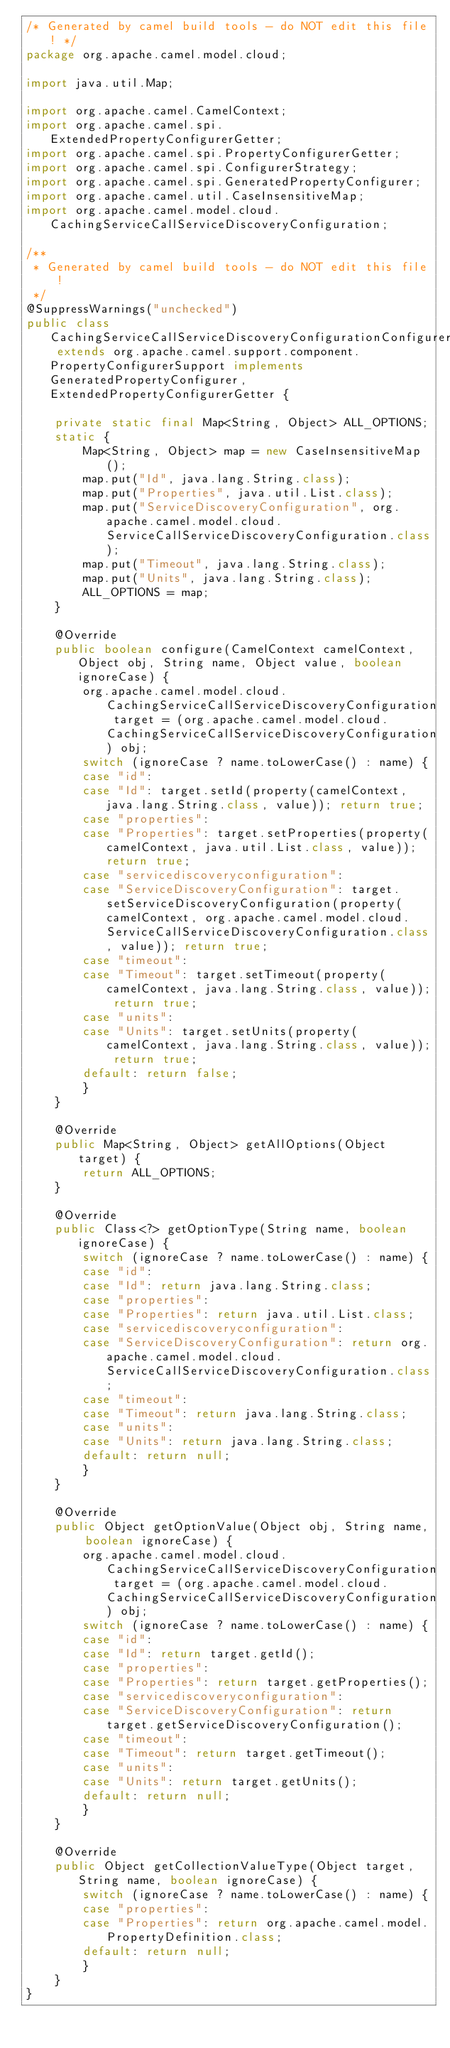<code> <loc_0><loc_0><loc_500><loc_500><_Java_>/* Generated by camel build tools - do NOT edit this file! */
package org.apache.camel.model.cloud;

import java.util.Map;

import org.apache.camel.CamelContext;
import org.apache.camel.spi.ExtendedPropertyConfigurerGetter;
import org.apache.camel.spi.PropertyConfigurerGetter;
import org.apache.camel.spi.ConfigurerStrategy;
import org.apache.camel.spi.GeneratedPropertyConfigurer;
import org.apache.camel.util.CaseInsensitiveMap;
import org.apache.camel.model.cloud.CachingServiceCallServiceDiscoveryConfiguration;

/**
 * Generated by camel build tools - do NOT edit this file!
 */
@SuppressWarnings("unchecked")
public class CachingServiceCallServiceDiscoveryConfigurationConfigurer extends org.apache.camel.support.component.PropertyConfigurerSupport implements GeneratedPropertyConfigurer, ExtendedPropertyConfigurerGetter {

    private static final Map<String, Object> ALL_OPTIONS;
    static {
        Map<String, Object> map = new CaseInsensitiveMap();
        map.put("Id", java.lang.String.class);
        map.put("Properties", java.util.List.class);
        map.put("ServiceDiscoveryConfiguration", org.apache.camel.model.cloud.ServiceCallServiceDiscoveryConfiguration.class);
        map.put("Timeout", java.lang.String.class);
        map.put("Units", java.lang.String.class);
        ALL_OPTIONS = map;
    }

    @Override
    public boolean configure(CamelContext camelContext, Object obj, String name, Object value, boolean ignoreCase) {
        org.apache.camel.model.cloud.CachingServiceCallServiceDiscoveryConfiguration target = (org.apache.camel.model.cloud.CachingServiceCallServiceDiscoveryConfiguration) obj;
        switch (ignoreCase ? name.toLowerCase() : name) {
        case "id":
        case "Id": target.setId(property(camelContext, java.lang.String.class, value)); return true;
        case "properties":
        case "Properties": target.setProperties(property(camelContext, java.util.List.class, value)); return true;
        case "servicediscoveryconfiguration":
        case "ServiceDiscoveryConfiguration": target.setServiceDiscoveryConfiguration(property(camelContext, org.apache.camel.model.cloud.ServiceCallServiceDiscoveryConfiguration.class, value)); return true;
        case "timeout":
        case "Timeout": target.setTimeout(property(camelContext, java.lang.String.class, value)); return true;
        case "units":
        case "Units": target.setUnits(property(camelContext, java.lang.String.class, value)); return true;
        default: return false;
        }
    }

    @Override
    public Map<String, Object> getAllOptions(Object target) {
        return ALL_OPTIONS;
    }

    @Override
    public Class<?> getOptionType(String name, boolean ignoreCase) {
        switch (ignoreCase ? name.toLowerCase() : name) {
        case "id":
        case "Id": return java.lang.String.class;
        case "properties":
        case "Properties": return java.util.List.class;
        case "servicediscoveryconfiguration":
        case "ServiceDiscoveryConfiguration": return org.apache.camel.model.cloud.ServiceCallServiceDiscoveryConfiguration.class;
        case "timeout":
        case "Timeout": return java.lang.String.class;
        case "units":
        case "Units": return java.lang.String.class;
        default: return null;
        }
    }

    @Override
    public Object getOptionValue(Object obj, String name, boolean ignoreCase) {
        org.apache.camel.model.cloud.CachingServiceCallServiceDiscoveryConfiguration target = (org.apache.camel.model.cloud.CachingServiceCallServiceDiscoveryConfiguration) obj;
        switch (ignoreCase ? name.toLowerCase() : name) {
        case "id":
        case "Id": return target.getId();
        case "properties":
        case "Properties": return target.getProperties();
        case "servicediscoveryconfiguration":
        case "ServiceDiscoveryConfiguration": return target.getServiceDiscoveryConfiguration();
        case "timeout":
        case "Timeout": return target.getTimeout();
        case "units":
        case "Units": return target.getUnits();
        default: return null;
        }
    }

    @Override
    public Object getCollectionValueType(Object target, String name, boolean ignoreCase) {
        switch (ignoreCase ? name.toLowerCase() : name) {
        case "properties":
        case "Properties": return org.apache.camel.model.PropertyDefinition.class;
        default: return null;
        }
    }
}

</code> 